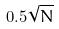Convert formula to latex. <formula><loc_0><loc_0><loc_500><loc_500>0 . 5 \sqrt { N }</formula> 